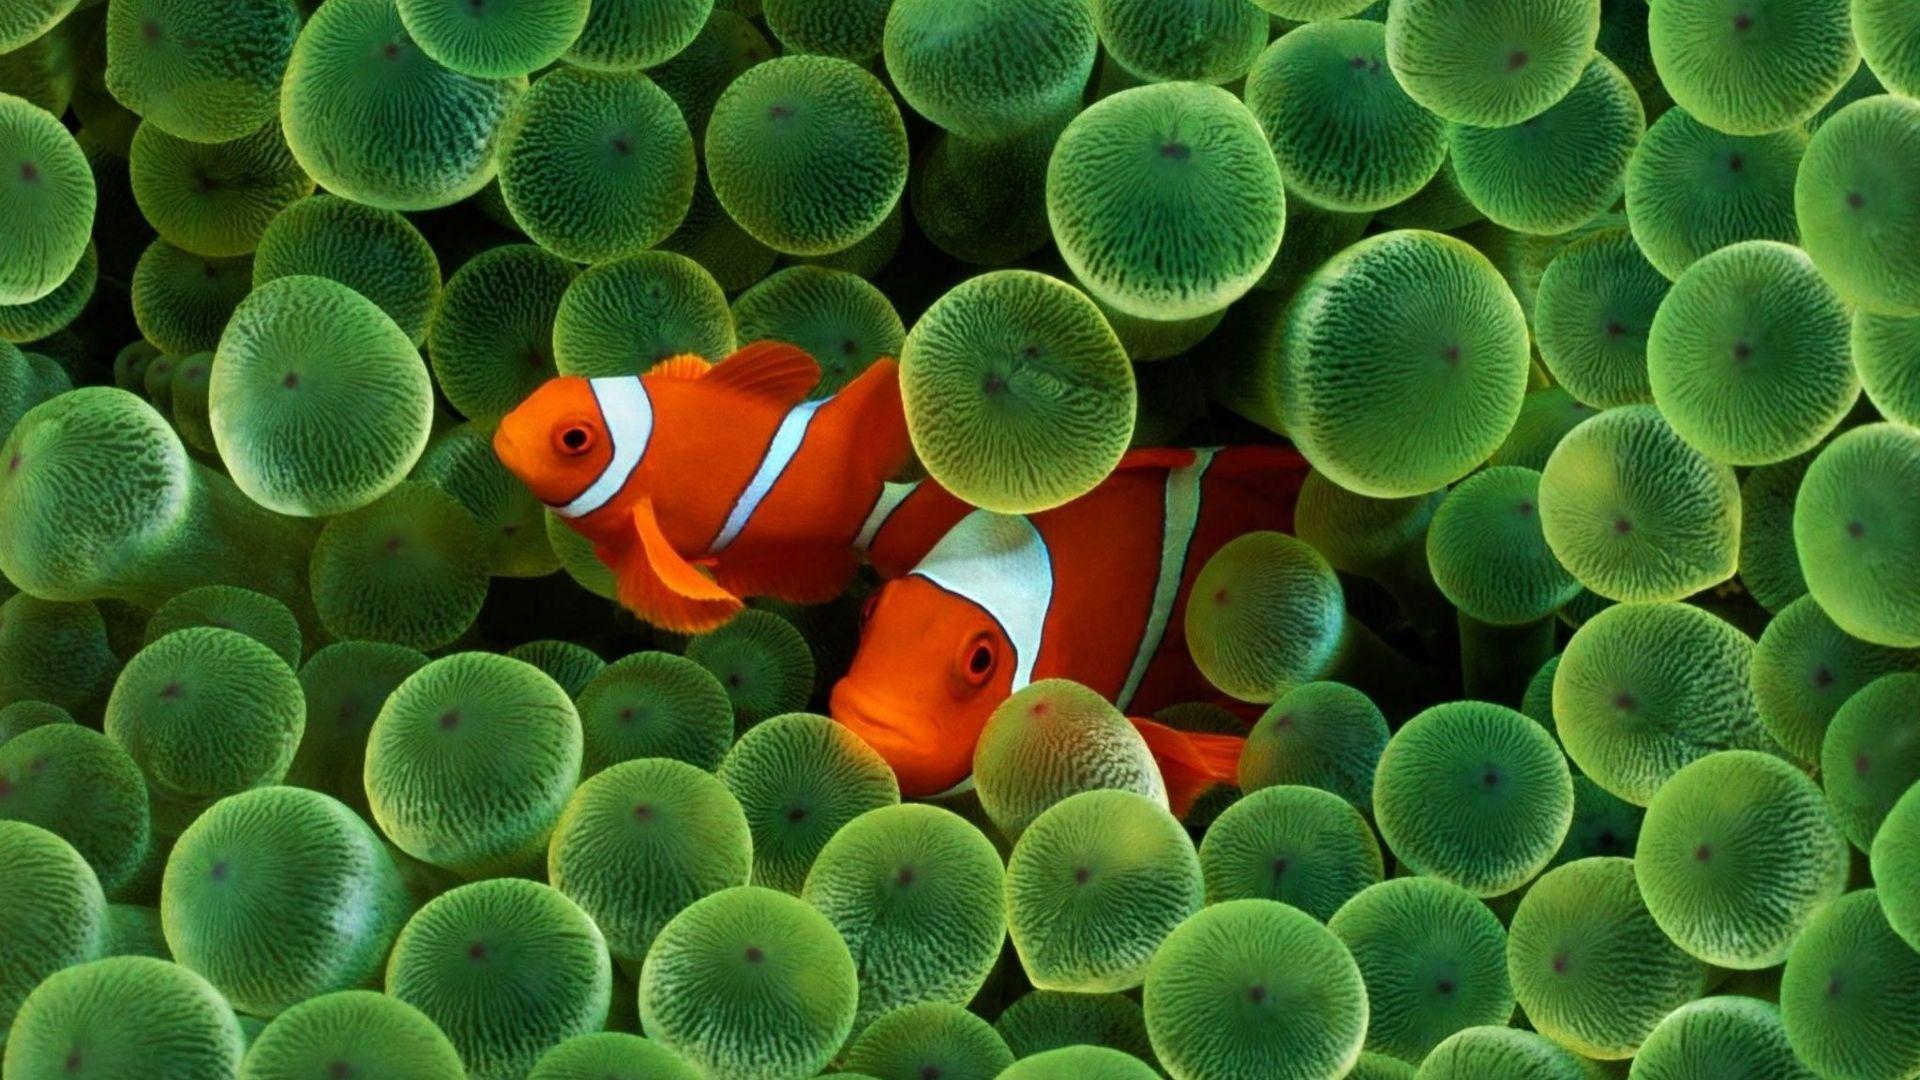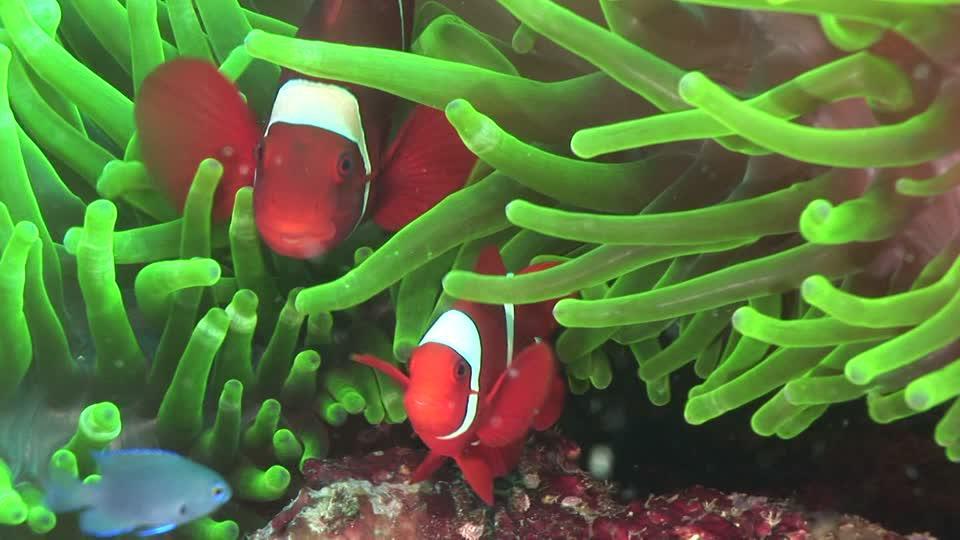The first image is the image on the left, the second image is the image on the right. Assess this claim about the two images: "There is exactly one fish in the right image.". Correct or not? Answer yes or no. No. 